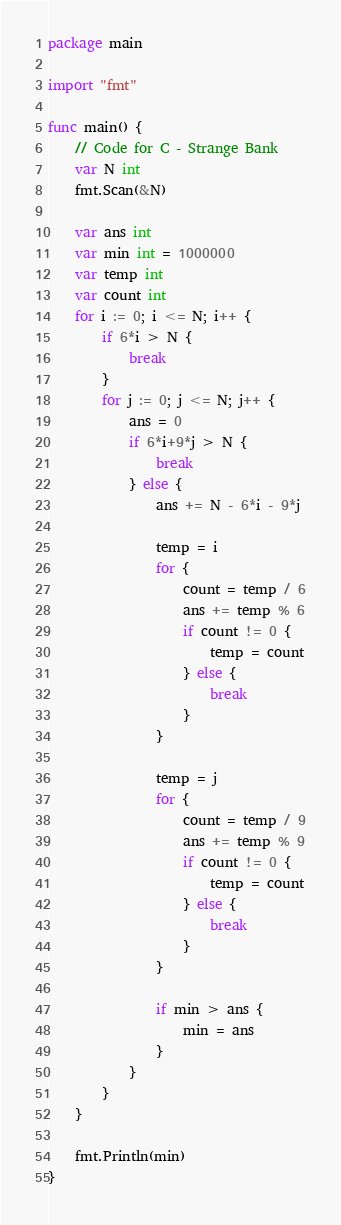Convert code to text. <code><loc_0><loc_0><loc_500><loc_500><_Go_>package main

import "fmt"

func main() {
	// Code for C - Strange Bank
	var N int
	fmt.Scan(&N)

	var ans int
	var min int = 1000000
	var temp int
	var count int
	for i := 0; i <= N; i++ {
		if 6*i > N {
			break
		}
		for j := 0; j <= N; j++ {
			ans = 0
			if 6*i+9*j > N {
				break
			} else {
				ans += N - 6*i - 9*j

				temp = i
				for {
					count = temp / 6
					ans += temp % 6
					if count != 0 {
						temp = count
					} else {
						break
					}
				}

				temp = j
				for {
					count = temp / 9
					ans += temp % 9
					if count != 0 {
						temp = count
					} else {
						break
					}
				}

				if min > ans {
					min = ans
				}
			}
		}
	}

	fmt.Println(min)
}
</code> 